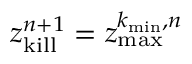Convert formula to latex. <formula><loc_0><loc_0><loc_500><loc_500>z _ { k i l l } ^ { n + 1 } = z _ { \max } ^ { k _ { \min } , n }</formula> 